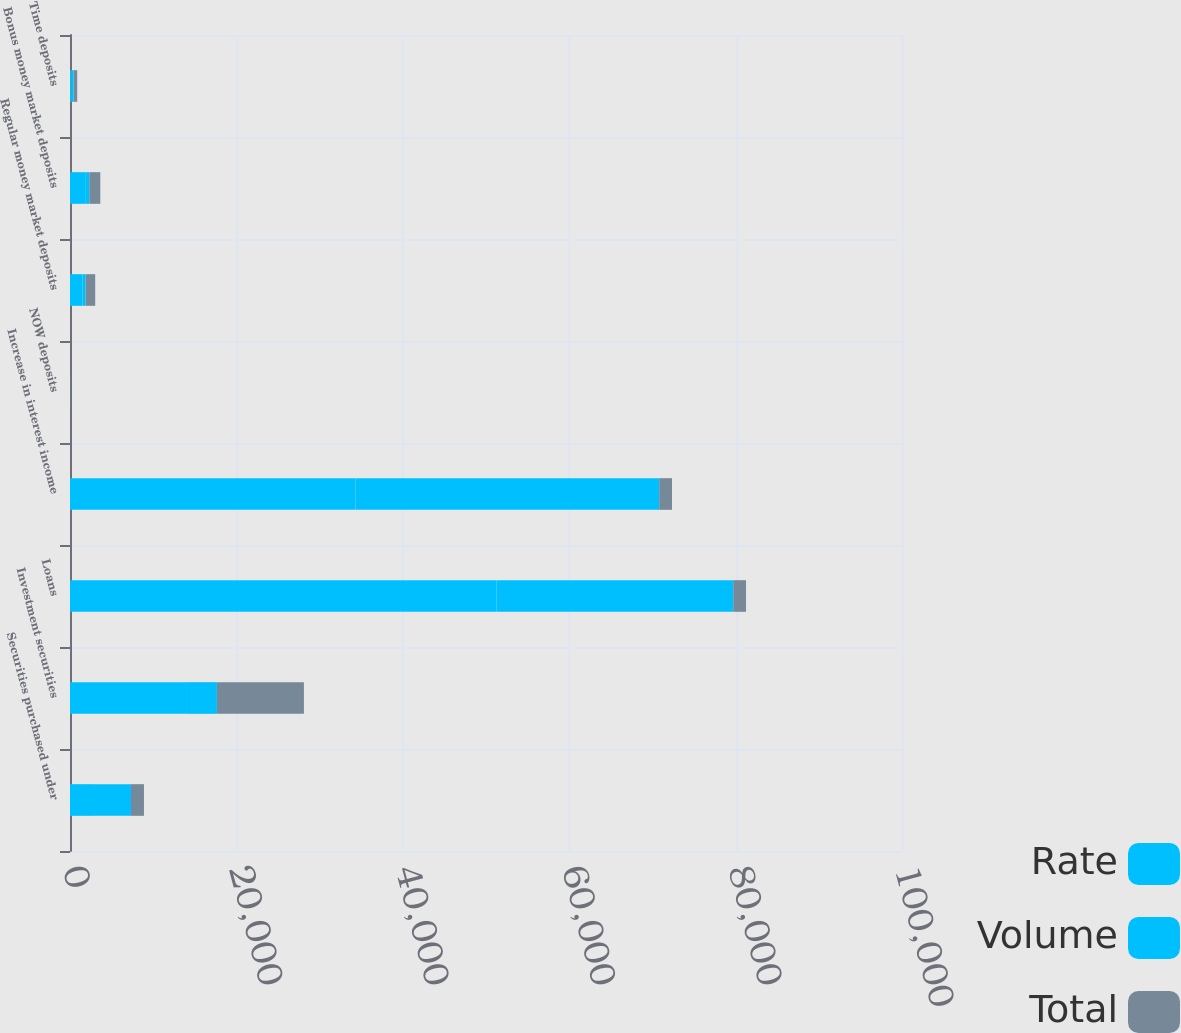<chart> <loc_0><loc_0><loc_500><loc_500><stacked_bar_chart><ecel><fcel>Securities purchased under<fcel>Investment securities<fcel>Loans<fcel>Increase in interest income<fcel>NOW deposits<fcel>Regular money market deposits<fcel>Bonus money market deposits<fcel>Time deposits<nl><fcel>Rate<fcel>2887<fcel>14058<fcel>51249<fcel>34304<fcel>16<fcel>1515<fcel>1820<fcel>145<nl><fcel>Volume<fcel>4445<fcel>3602<fcel>28469<fcel>36516<fcel>1<fcel>356<fcel>501<fcel>288<nl><fcel>Total<fcel>1558<fcel>10456<fcel>1536.5<fcel>1536.5<fcel>17<fcel>1159<fcel>1319<fcel>433<nl></chart> 